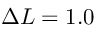<formula> <loc_0><loc_0><loc_500><loc_500>\Delta L = 1 . 0</formula> 